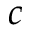Convert formula to latex. <formula><loc_0><loc_0><loc_500><loc_500>c</formula> 